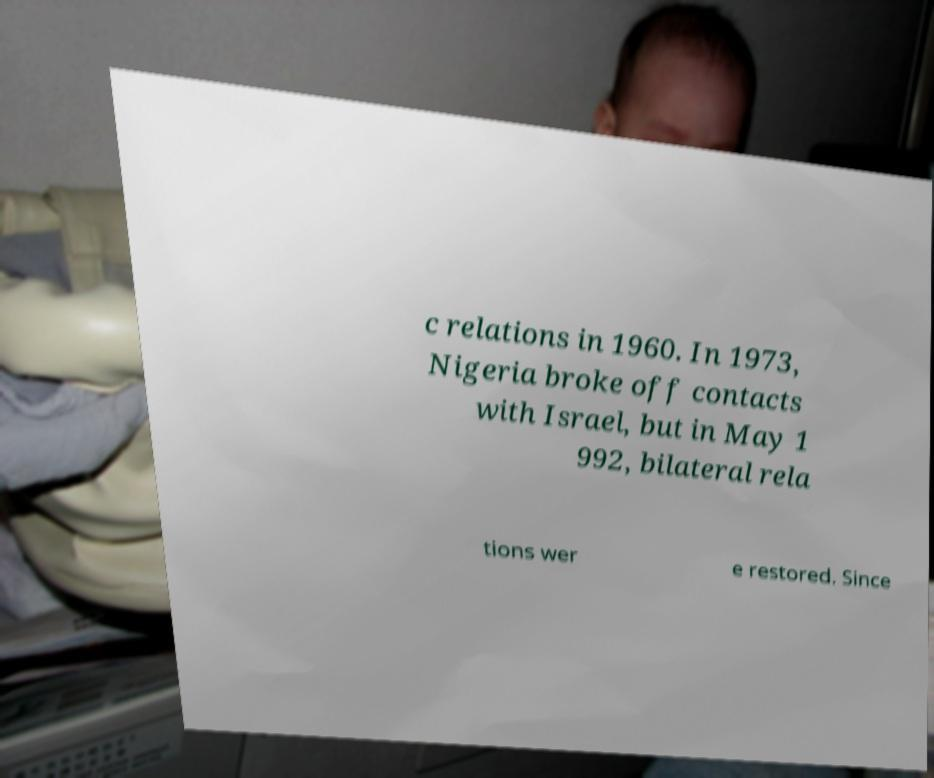For documentation purposes, I need the text within this image transcribed. Could you provide that? c relations in 1960. In 1973, Nigeria broke off contacts with Israel, but in May 1 992, bilateral rela tions wer e restored. Since 